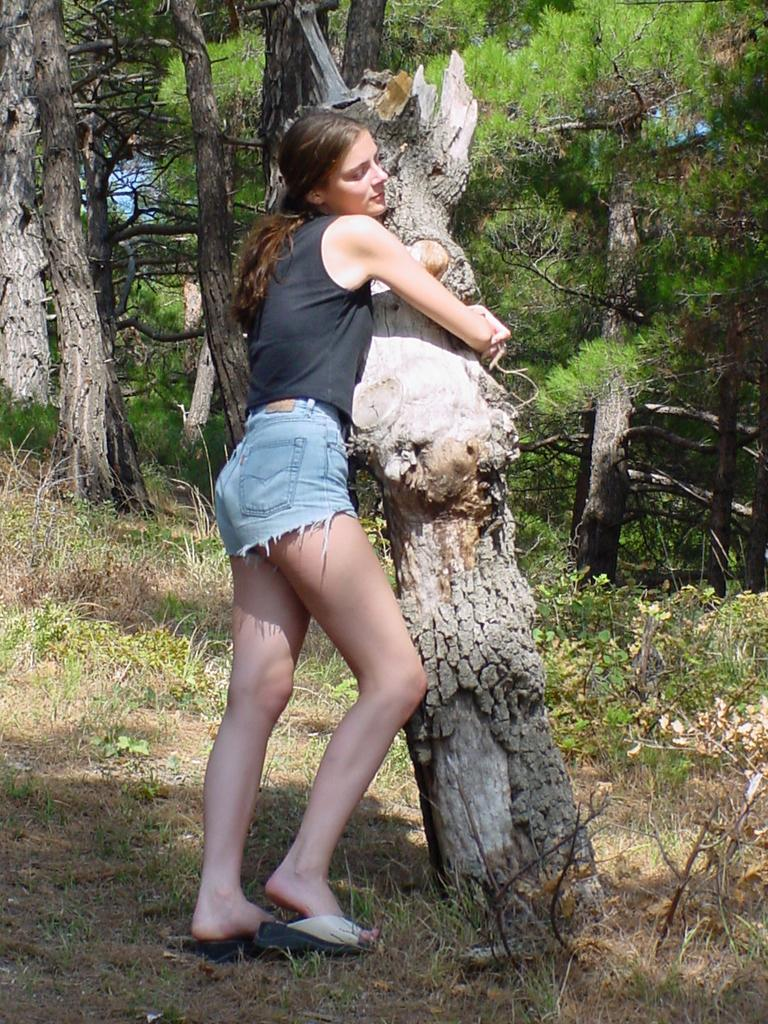Who is the main subject in the image? There is a woman in the image. What is the woman doing in the image? The woman is holding the trunk of a tree. What can be seen in the background of the image? There are trees, plants, grass, and the sky visible in the background of the image. What type of space-themed act is the woman performing in the image? There is no space-themed act or any indication of a performance in the image. The woman is simply holding the trunk of a tree. 